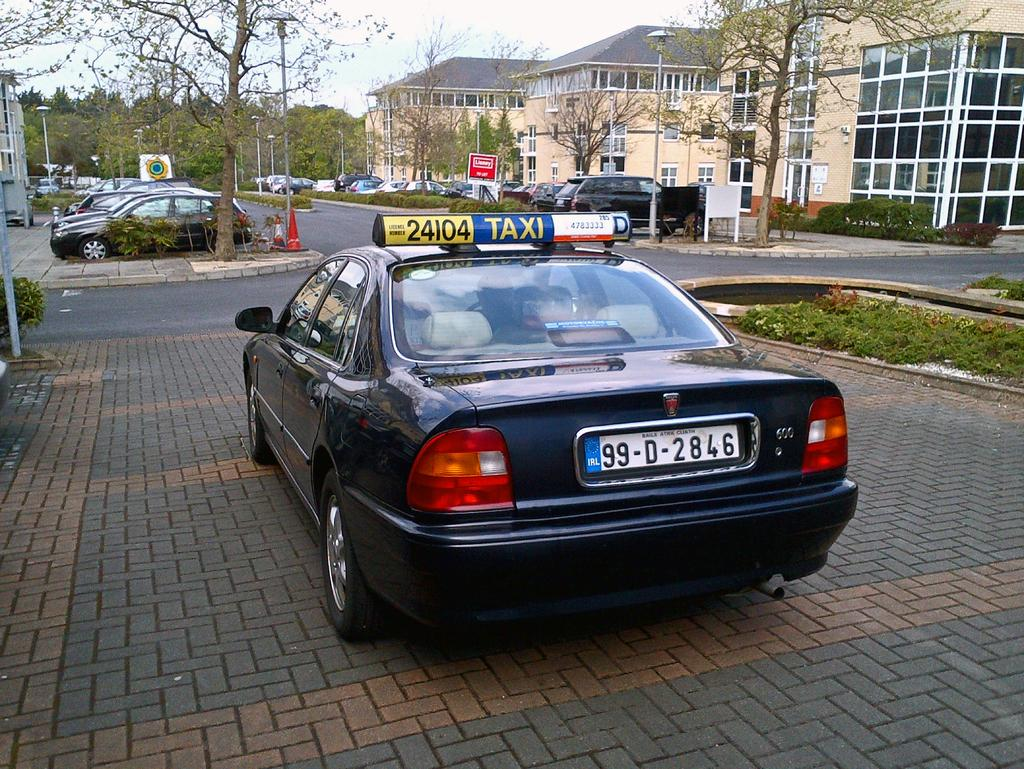What can be seen on the path in the image? There are vehicles on the path in the image. What is located on the left side of the image? There is a pole on the left side of the image. What safety devices are visible in the image? Traffic cones are visible in the image. What type of lighting is present in the image? Street lights are present lights are present in the image. What type of vegetation can be seen in the background of the image? Trees are present in the background of the image. What type of structures can be seen in the background of the image? Buildings are visible in the background of the image. Where is the writer sitting in the image? There is no writer present in the image. What type of slope can be seen in the image? There is no slope visible in the image. How many spiders are crawling on the vehicles in the image? There are no spiders present in the image. 